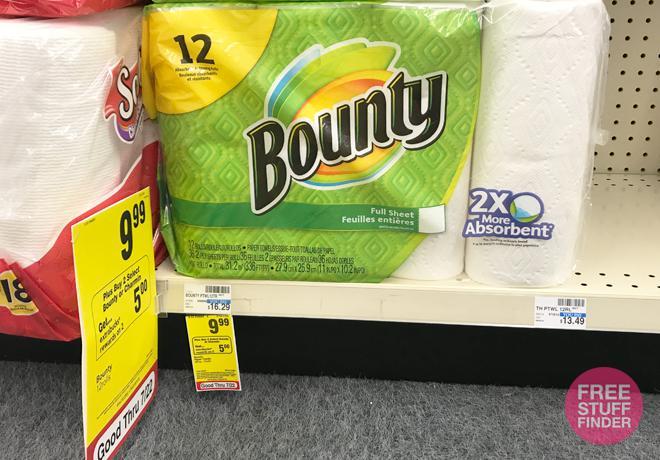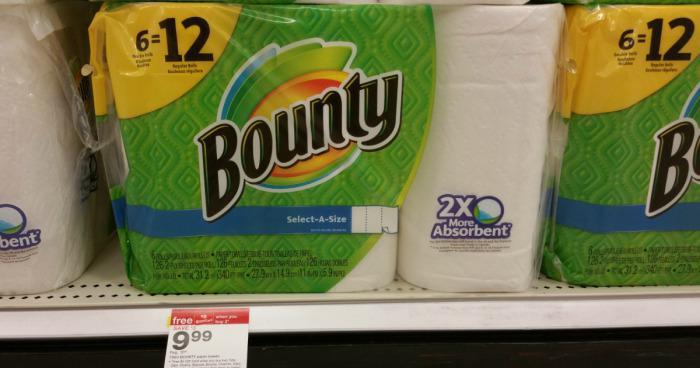The first image is the image on the left, the second image is the image on the right. Considering the images on both sides, is "There are both Bounty and Scott brand paper towels." valid? Answer yes or no. Yes. The first image is the image on the left, the second image is the image on the right. Considering the images on both sides, is "Each image shows multipack paper towels in green and yellow packaging on store shelves with white pegboard." valid? Answer yes or no. Yes. 